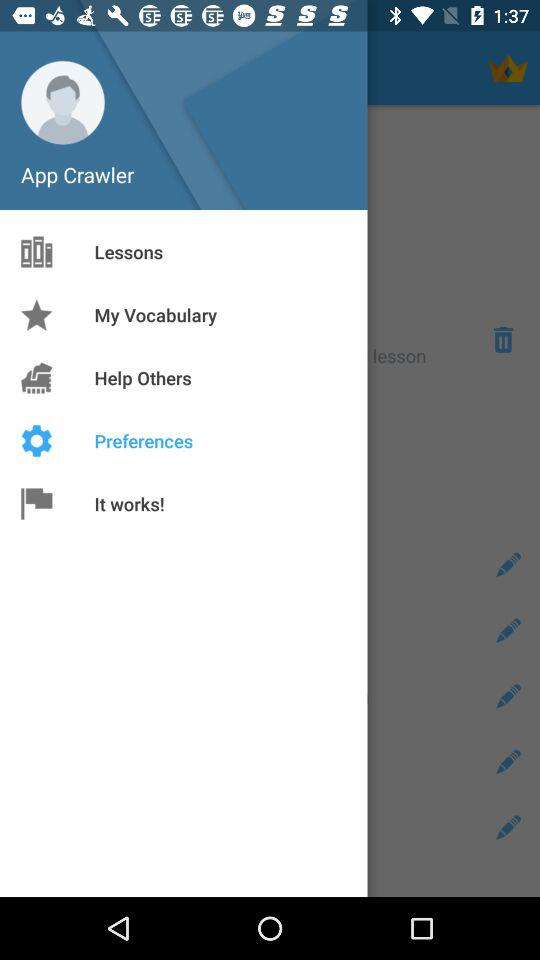What is the name of the user? The name of the user is "App Crawler". 